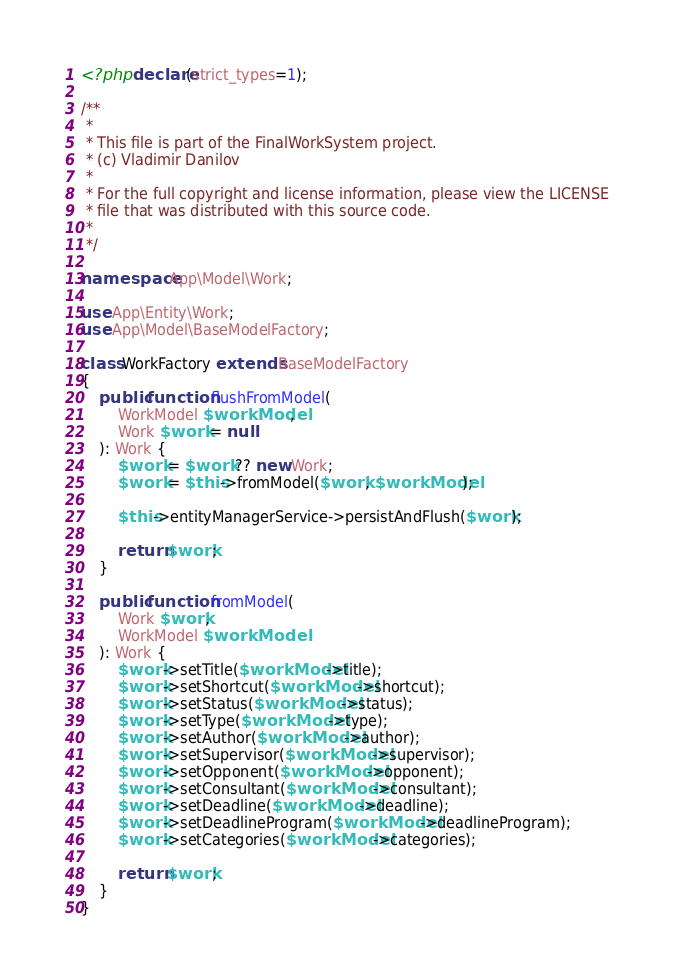<code> <loc_0><loc_0><loc_500><loc_500><_PHP_><?php declare(strict_types=1);

/**
 *
 * This file is part of the FinalWorkSystem project.
 * (c) Vladimir Danilov
 *
 * For the full copyright and license information, please view the LICENSE
 * file that was distributed with this source code.
 *
 */

namespace App\Model\Work;

use App\Entity\Work;
use App\Model\BaseModelFactory;

class WorkFactory extends BaseModelFactory
{
    public function flushFromModel(
        WorkModel $workModel,
        Work $work = null
    ): Work {
        $work = $work ?? new Work;
        $work = $this->fromModel($work, $workModel);

        $this->entityManagerService->persistAndFlush($work);

        return $work;
    }

    public function fromModel(
        Work $work,
        WorkModel $workModel
    ): Work {
        $work->setTitle($workModel->title);
        $work->setShortcut($workModel->shortcut);
        $work->setStatus($workModel->status);
        $work->setType($workModel->type);
        $work->setAuthor($workModel->author);
        $work->setSupervisor($workModel->supervisor);
        $work->setOpponent($workModel->opponent);
        $work->setConsultant($workModel->consultant);
        $work->setDeadline($workModel->deadline);
        $work->setDeadlineProgram($workModel->deadlineProgram);
        $work->setCategories($workModel->categories);

        return $work;
    }
}
</code> 